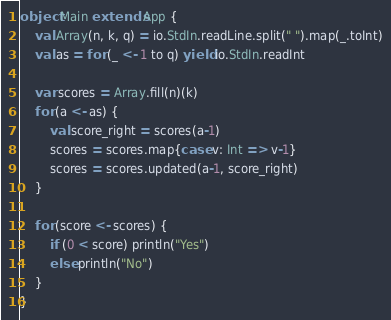<code> <loc_0><loc_0><loc_500><loc_500><_Scala_>object Main extends App {
    val Array(n, k, q) = io.StdIn.readLine.split(" ").map(_.toInt)
    val as = for (_ <- 1 to q) yield io.StdIn.readInt

    var scores = Array.fill(n)(k)
    for (a <- as) {
        val score_right = scores(a-1)
        scores = scores.map{case v: Int => v-1}
        scores = scores.updated(a-1, score_right)
    }

    for (score <- scores) {
        if (0 < score) println("Yes")
        else println("No")
    }
}</code> 